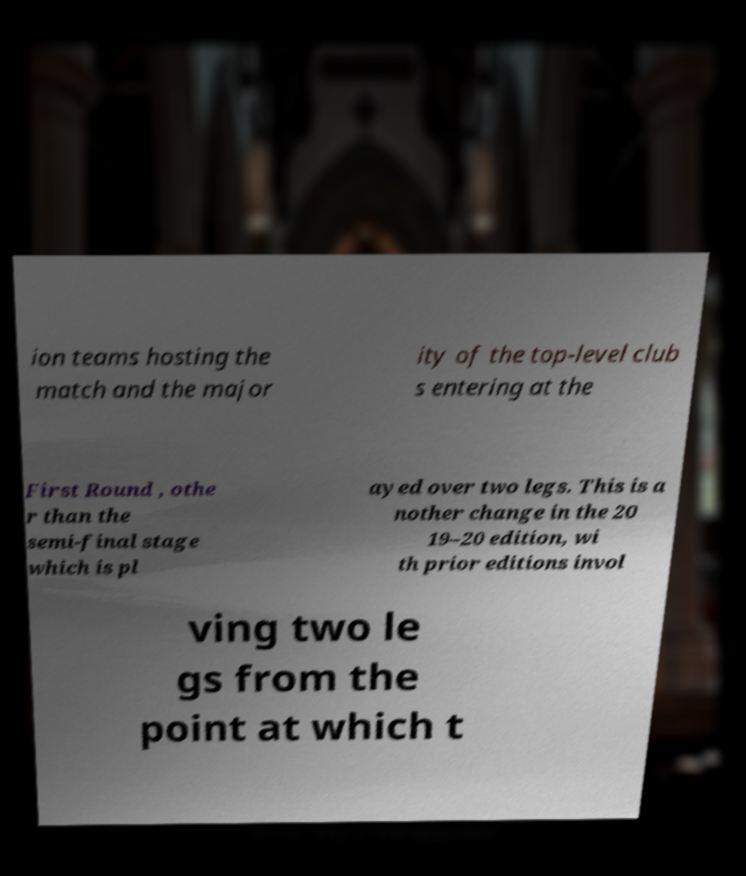Could you extract and type out the text from this image? ion teams hosting the match and the major ity of the top-level club s entering at the First Round , othe r than the semi-final stage which is pl ayed over two legs. This is a nother change in the 20 19–20 edition, wi th prior editions invol ving two le gs from the point at which t 